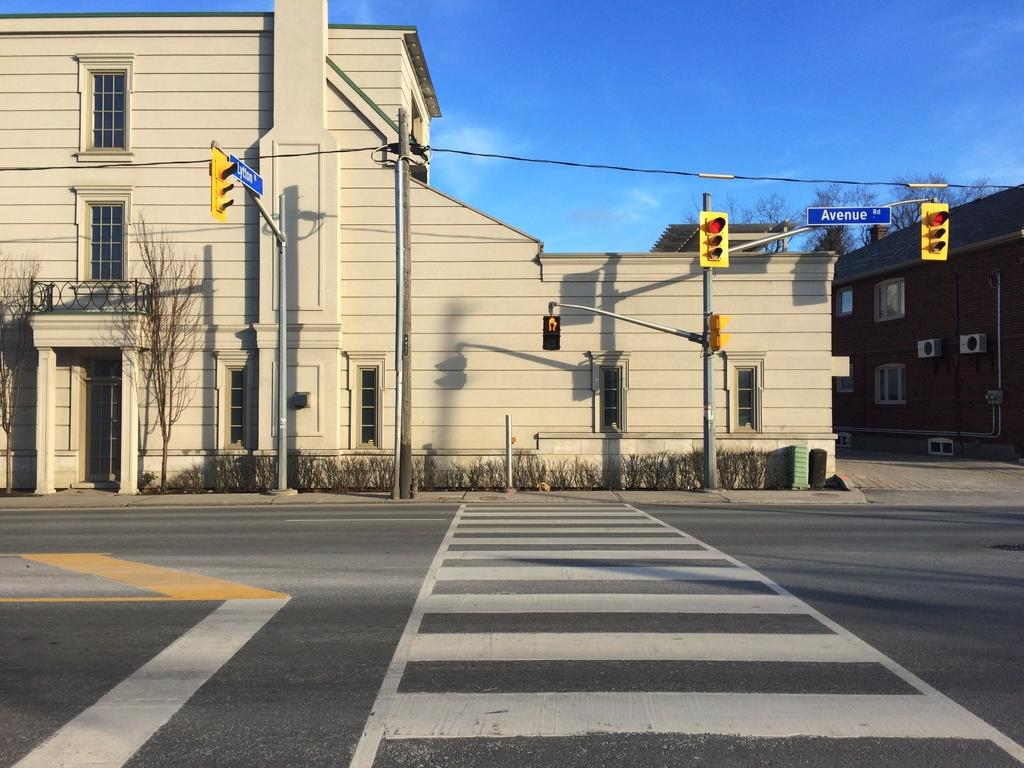<image>
Create a compact narrative representing the image presented. A crossing at Avenue Rd with a building behing it 